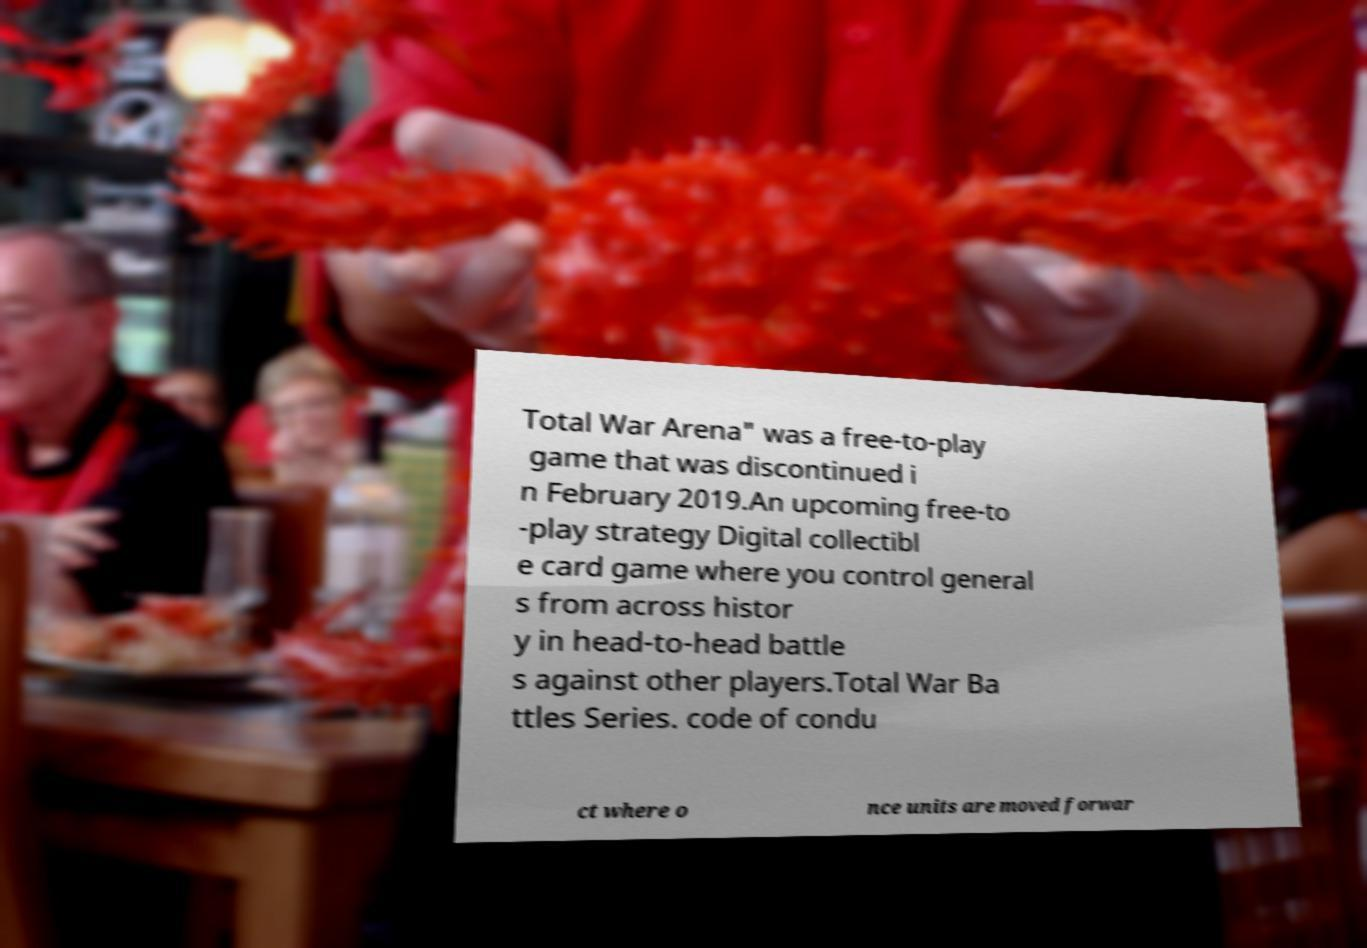I need the written content from this picture converted into text. Can you do that? Total War Arena" was a free-to-play game that was discontinued i n February 2019.An upcoming free-to -play strategy Digital collectibl e card game where you control general s from across histor y in head-to-head battle s against other players.Total War Ba ttles Series. code of condu ct where o nce units are moved forwar 